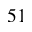<formula> <loc_0><loc_0><loc_500><loc_500>^ { 5 1 }</formula> 